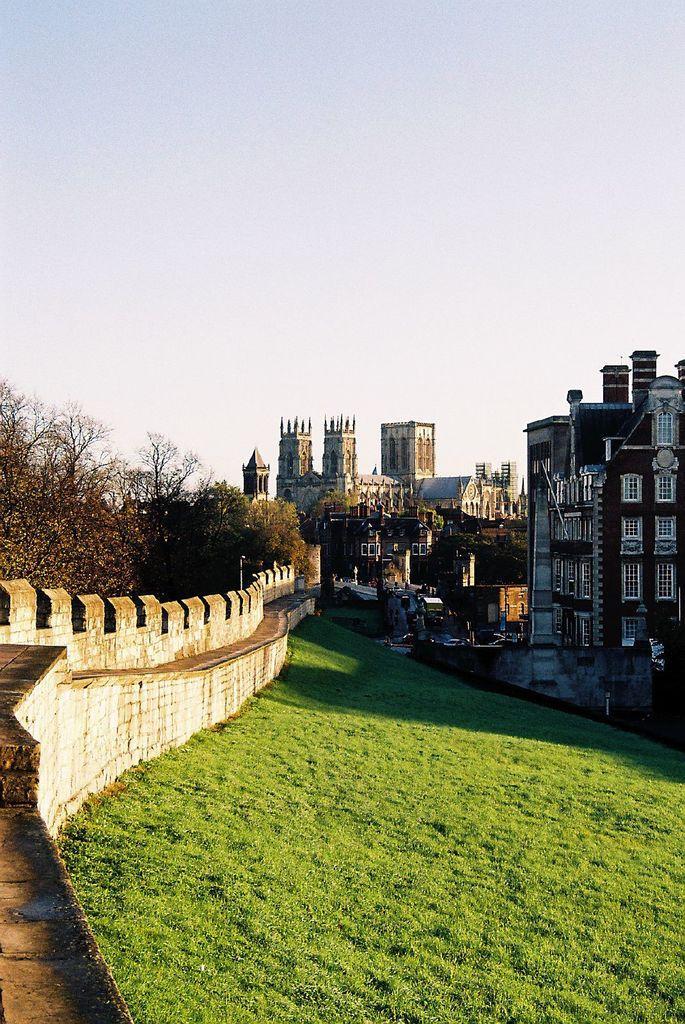How would you summarize this image in a sentence or two? In this picture there are buildings and trees and there are vehicles on the road. On the left side of the image there is a wall. At the top there is sky. At the bottom there is grass. 